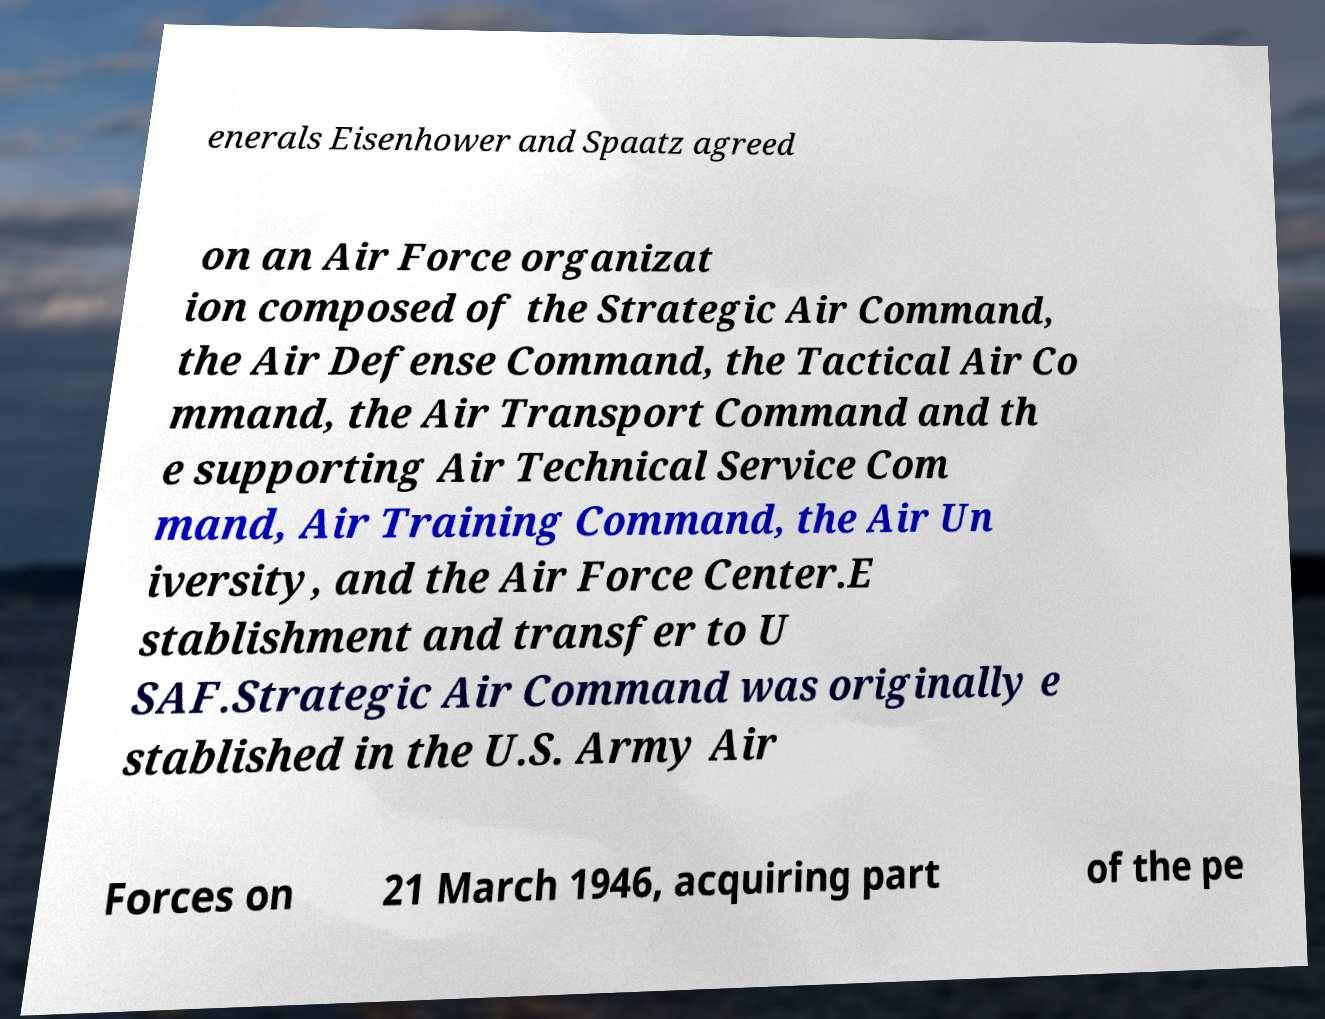Could you assist in decoding the text presented in this image and type it out clearly? enerals Eisenhower and Spaatz agreed on an Air Force organizat ion composed of the Strategic Air Command, the Air Defense Command, the Tactical Air Co mmand, the Air Transport Command and th e supporting Air Technical Service Com mand, Air Training Command, the Air Un iversity, and the Air Force Center.E stablishment and transfer to U SAF.Strategic Air Command was originally e stablished in the U.S. Army Air Forces on 21 March 1946, acquiring part of the pe 